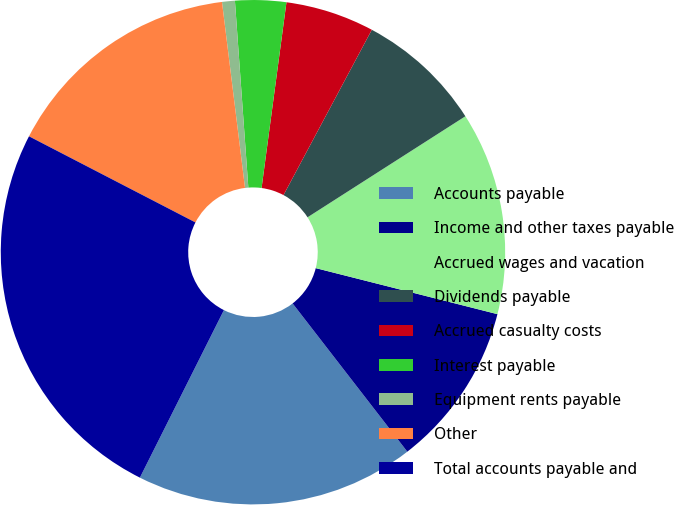Convert chart to OTSL. <chart><loc_0><loc_0><loc_500><loc_500><pie_chart><fcel>Accounts payable<fcel>Income and other taxes payable<fcel>Accrued wages and vacation<fcel>Dividends payable<fcel>Accrued casualty costs<fcel>Interest payable<fcel>Equipment rents payable<fcel>Other<fcel>Total accounts payable and<nl><fcel>17.88%<fcel>10.57%<fcel>13.01%<fcel>8.13%<fcel>5.69%<fcel>3.26%<fcel>0.82%<fcel>15.44%<fcel>25.2%<nl></chart> 